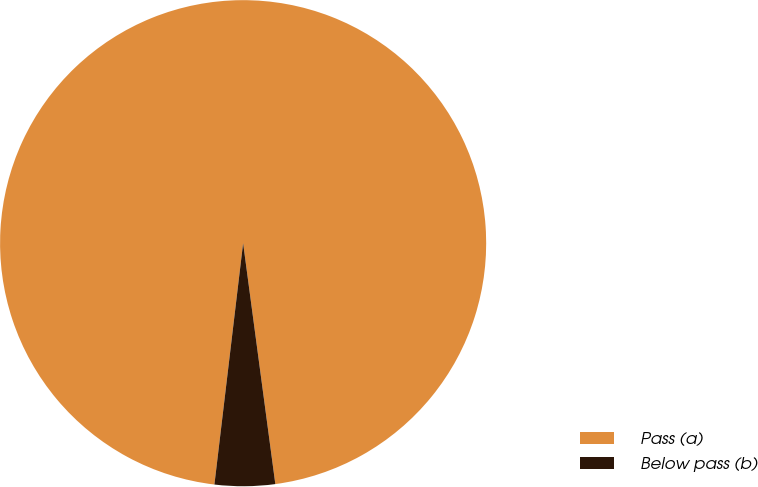Convert chart. <chart><loc_0><loc_0><loc_500><loc_500><pie_chart><fcel>Pass (a)<fcel>Below pass (b)<nl><fcel>96.0%<fcel>4.0%<nl></chart> 